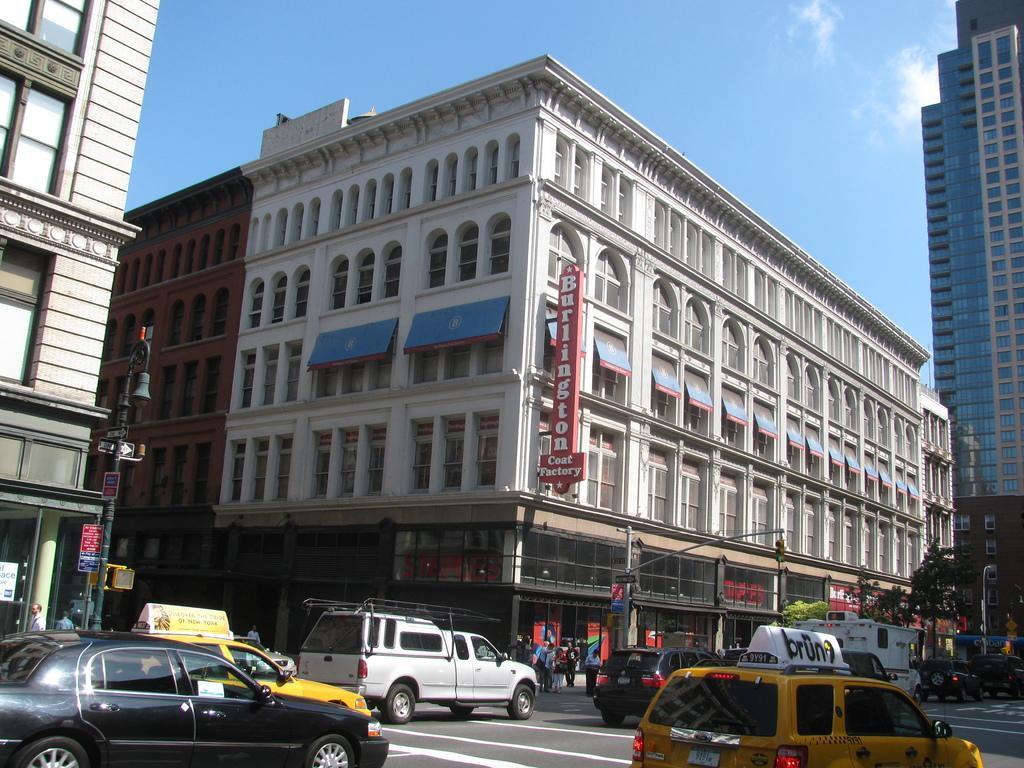<image>
Provide a brief description of the given image. Cars drive past a Burlington Coat Factory under a blue sky. 